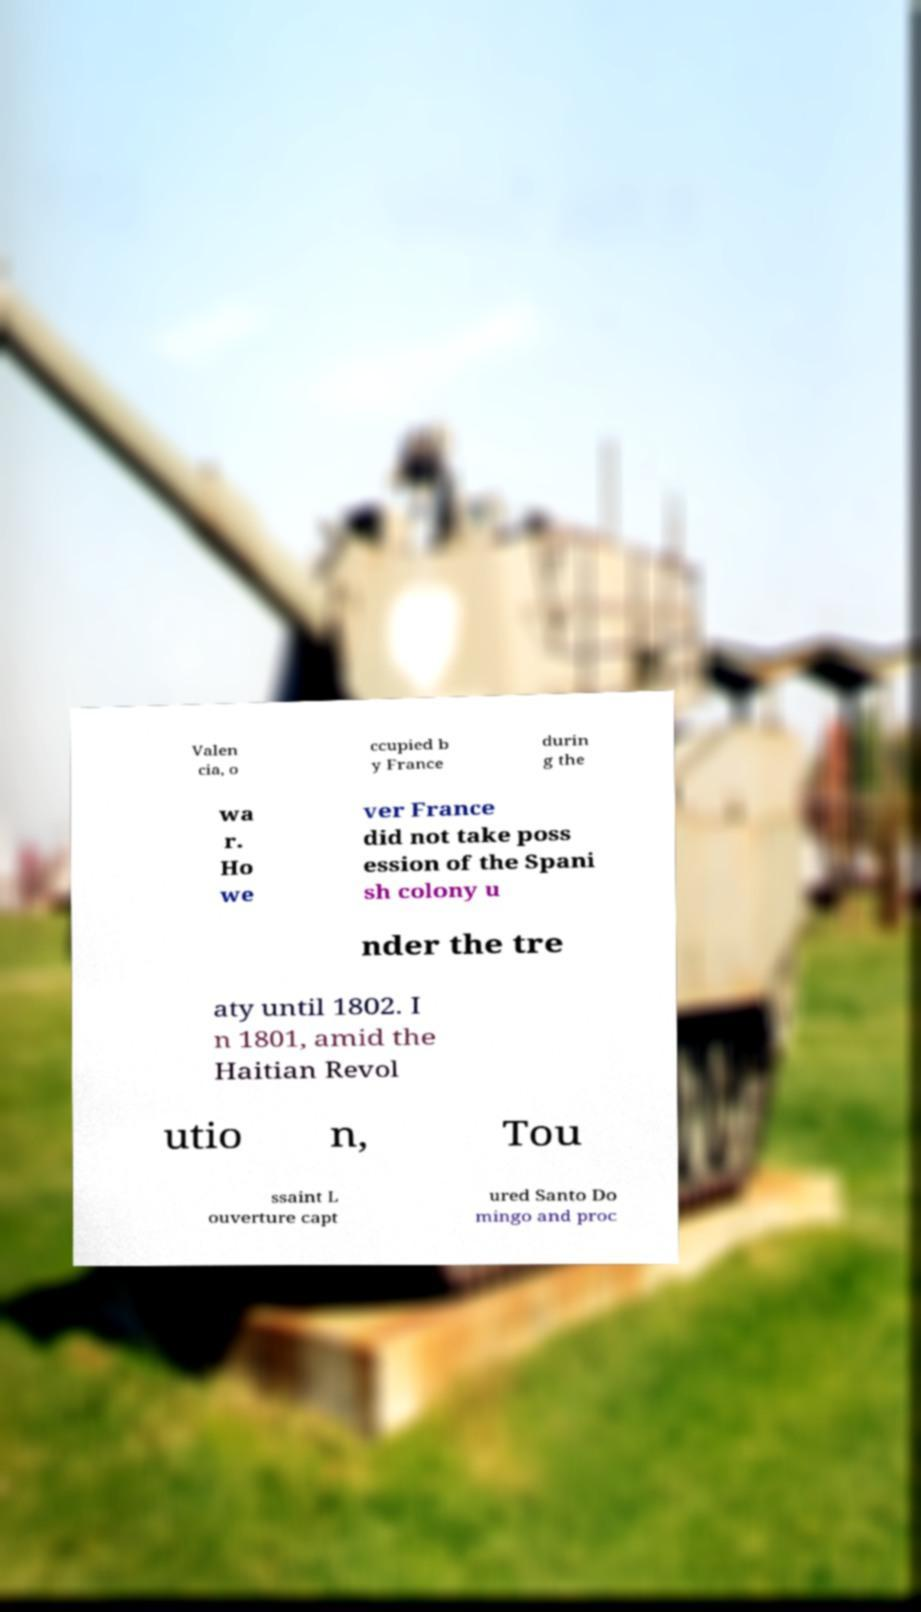Could you assist in decoding the text presented in this image and type it out clearly? Valen cia, o ccupied b y France durin g the wa r. Ho we ver France did not take poss ession of the Spani sh colony u nder the tre aty until 1802. I n 1801, amid the Haitian Revol utio n, Tou ssaint L ouverture capt ured Santo Do mingo and proc 